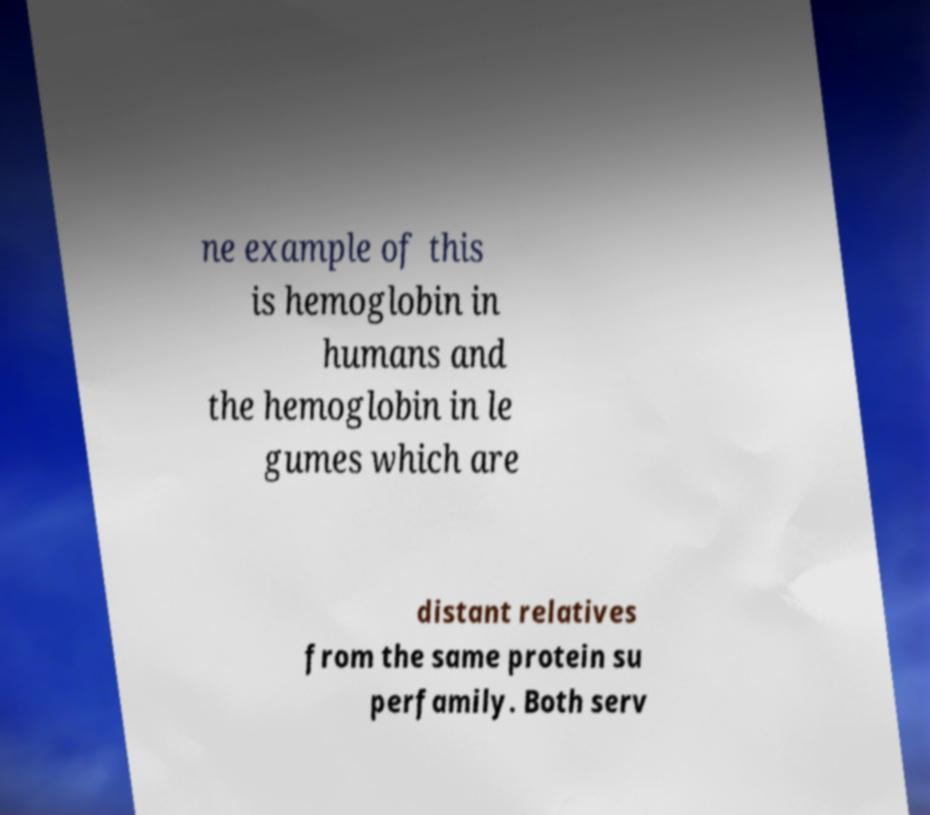Can you read and provide the text displayed in the image?This photo seems to have some interesting text. Can you extract and type it out for me? ne example of this is hemoglobin in humans and the hemoglobin in le gumes which are distant relatives from the same protein su perfamily. Both serv 